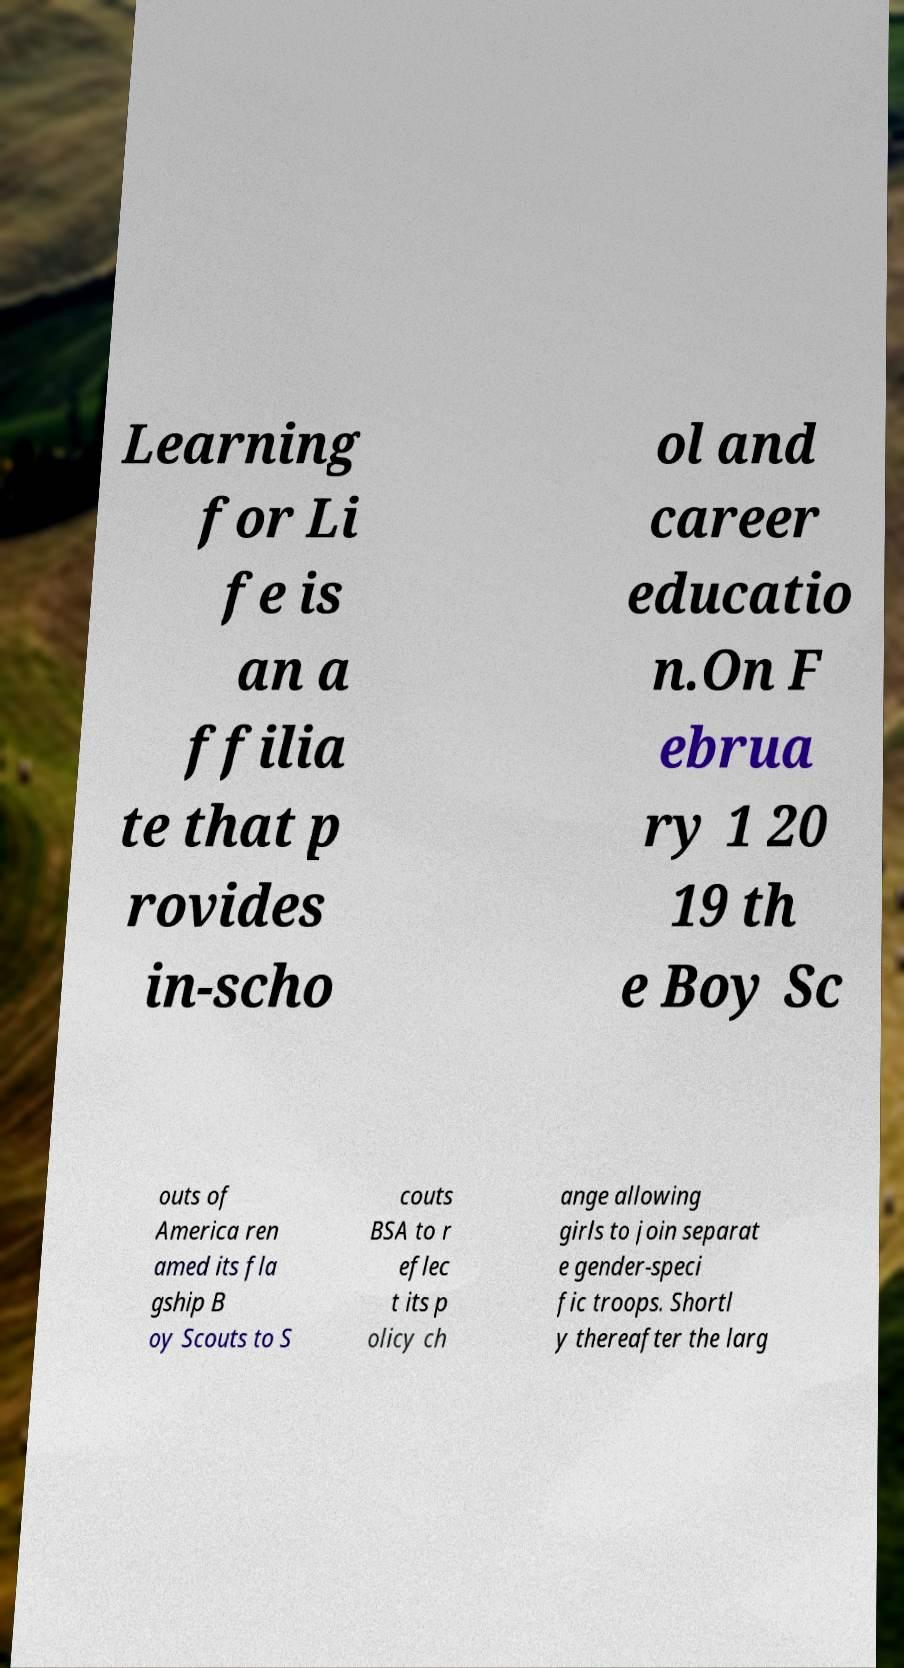Could you extract and type out the text from this image? Learning for Li fe is an a ffilia te that p rovides in-scho ol and career educatio n.On F ebrua ry 1 20 19 th e Boy Sc outs of America ren amed its fla gship B oy Scouts to S couts BSA to r eflec t its p olicy ch ange allowing girls to join separat e gender-speci fic troops. Shortl y thereafter the larg 